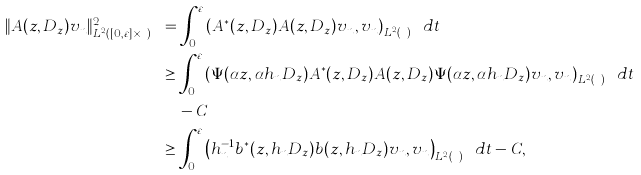<formula> <loc_0><loc_0><loc_500><loc_500>\| A ( z , D _ { z } ) v _ { n } \| ^ { 2 } _ { L ^ { 2 } ( [ 0 , \varepsilon ] \times { \mathbb { R } } ^ { d } ) } & = \int _ { 0 } ^ { \varepsilon } \left ( A ^ { * } ( z , D _ { z } ) A ( z , D _ { z } ) v _ { n } , v _ { n } \right ) _ { L ^ { 2 } ( { \mathbb { R } } ^ { d } _ { z } ) } d t \\ & \geq \int _ { 0 } ^ { \varepsilon } \left ( \Psi ( \alpha z , \alpha h _ { n } D _ { z } ) A ^ { * } ( z , D _ { z } ) A ( z , D _ { z } ) \Psi ( \alpha z , \alpha h _ { n } D _ { z } ) v _ { n } , v _ { n } \right ) _ { L ^ { 2 } ( { \mathbb { R } } ^ { d } _ { z } ) } d t \\ & \quad - C \\ & \geq \int _ { 0 } ^ { \varepsilon } \left ( h _ { n } ^ { - 1 } b ^ { * } ( z , h _ { n } D _ { z } ) b ( z , h _ { n } D _ { z } ) v _ { n } , v _ { n } \right ) _ { L ^ { 2 } ( { \mathbb { R } } ^ { d } _ { z } ) } d t - C ,</formula> 